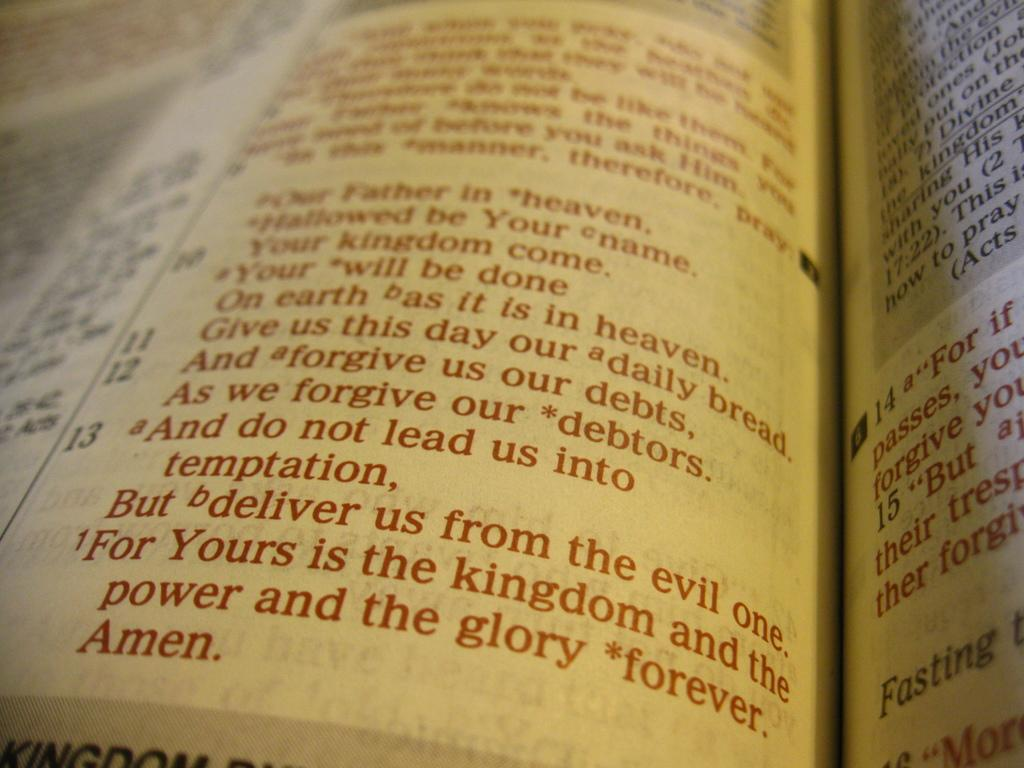<image>
Provide a brief description of the given image. Amen is in red text at the bottom of the left page. 